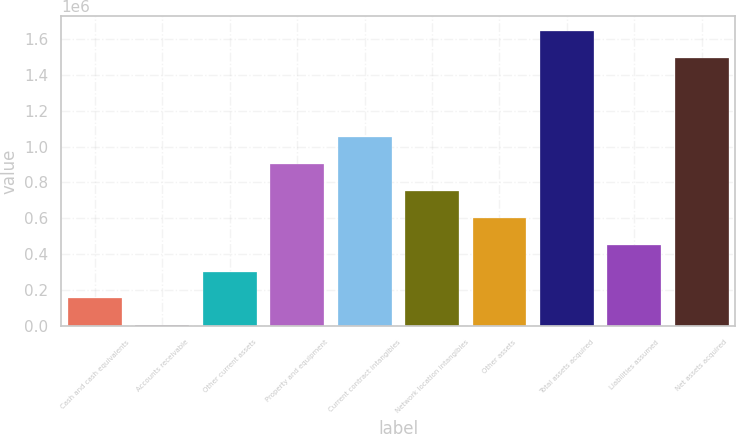Convert chart to OTSL. <chart><loc_0><loc_0><loc_500><loc_500><bar_chart><fcel>Cash and cash equivalents<fcel>Accounts receivable<fcel>Other current assets<fcel>Property and equipment<fcel>Current contract intangibles<fcel>Network location intangibles<fcel>Other assets<fcel>Total assets acquired<fcel>Liabilities assumed<fcel>Net assets acquired<nl><fcel>152996<fcel>2944<fcel>303048<fcel>903255<fcel>1.05331e+06<fcel>753203<fcel>603151<fcel>1.64495e+06<fcel>453099<fcel>1.49489e+06<nl></chart> 